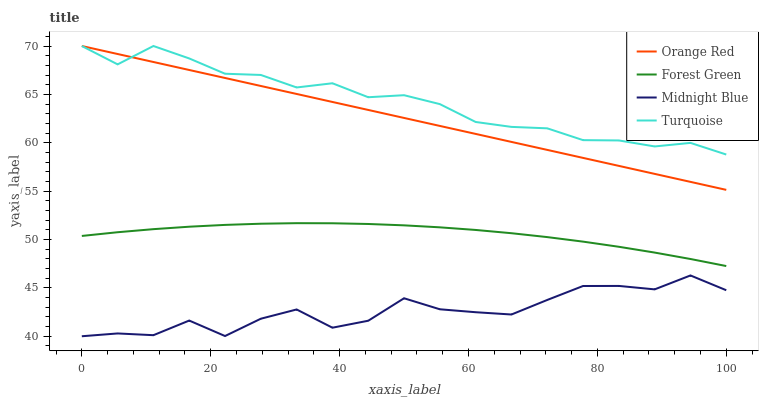Does Midnight Blue have the minimum area under the curve?
Answer yes or no. Yes. Does Turquoise have the maximum area under the curve?
Answer yes or no. Yes. Does Orange Red have the minimum area under the curve?
Answer yes or no. No. Does Orange Red have the maximum area under the curve?
Answer yes or no. No. Is Orange Red the smoothest?
Answer yes or no. Yes. Is Midnight Blue the roughest?
Answer yes or no. Yes. Is Turquoise the smoothest?
Answer yes or no. No. Is Turquoise the roughest?
Answer yes or no. No. Does Orange Red have the lowest value?
Answer yes or no. No. Does Midnight Blue have the highest value?
Answer yes or no. No. Is Midnight Blue less than Forest Green?
Answer yes or no. Yes. Is Turquoise greater than Forest Green?
Answer yes or no. Yes. Does Midnight Blue intersect Forest Green?
Answer yes or no. No. 